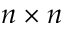Convert formula to latex. <formula><loc_0><loc_0><loc_500><loc_500>n \times n</formula> 